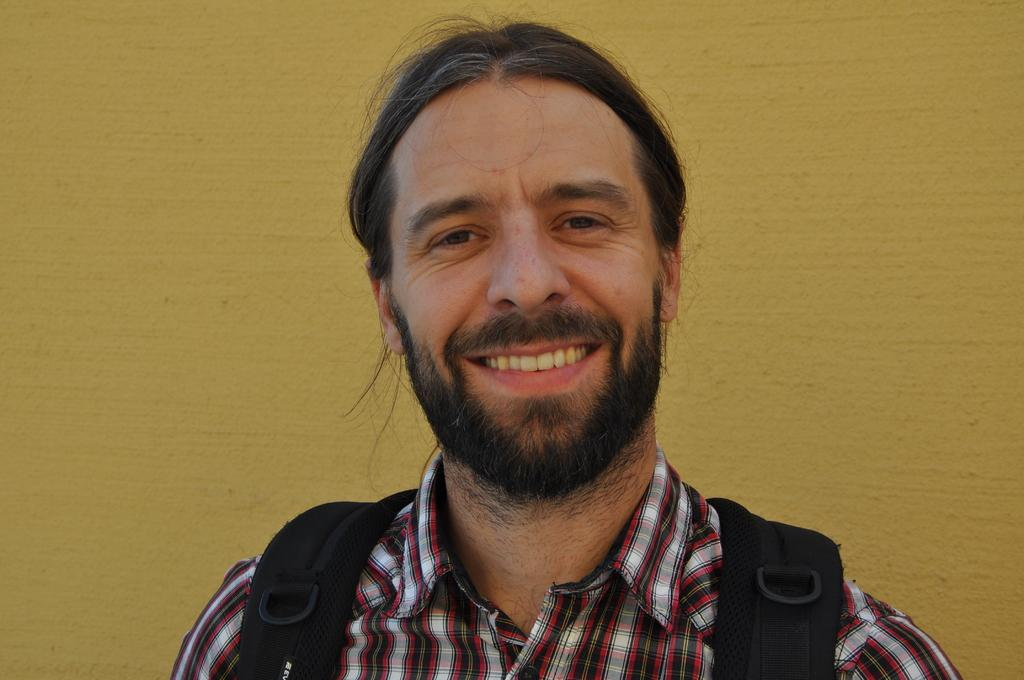What is the main subject of the image? There is a man in the image. What is the man wearing? The man is wearing a bag. Can you describe the background of the image? There is a yellow color wall in the image. What type of health advice is the man giving in the image? There is no indication in the image that the man is giving any health advice. 